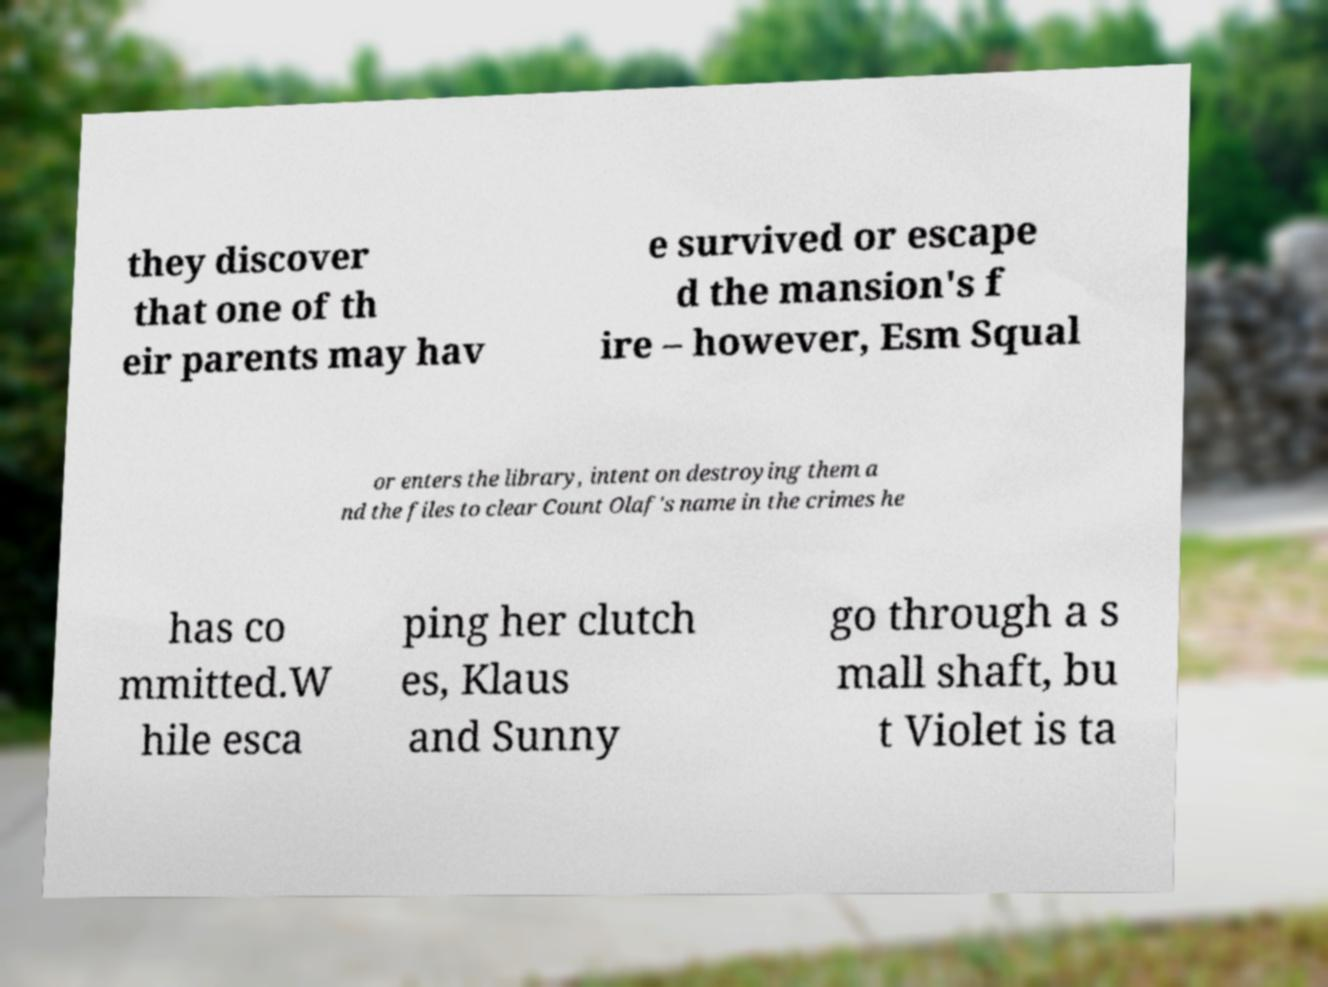I need the written content from this picture converted into text. Can you do that? they discover that one of th eir parents may hav e survived or escape d the mansion's f ire – however, Esm Squal or enters the library, intent on destroying them a nd the files to clear Count Olaf's name in the crimes he has co mmitted.W hile esca ping her clutch es, Klaus and Sunny go through a s mall shaft, bu t Violet is ta 